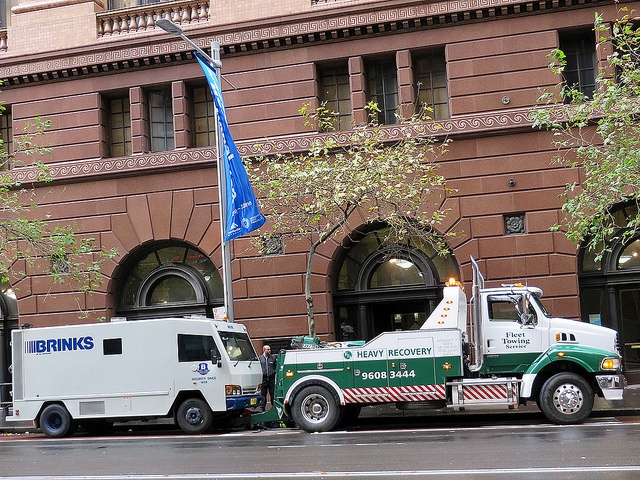Describe the objects in this image and their specific colors. I can see truck in gray, lightgray, black, and teal tones, truck in gray, lightgray, black, and darkgray tones, and people in gray, black, and darkgray tones in this image. 